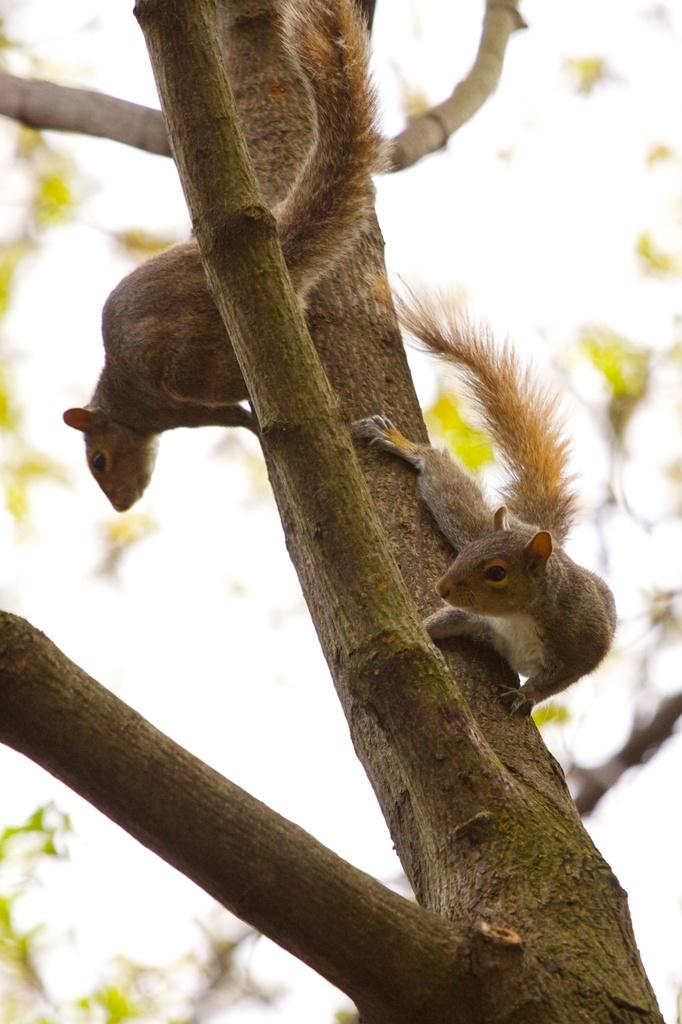What animals can be seen in the image? There are two squirrels in the image. Where are the squirrels located? The squirrels are on a tree trunk. Can you describe the background of the image? The background of the image is blurred. What type of brush is the ladybug using to paint the tree trunk in the image? There is no ladybug or brush present in the image; it features two squirrels on a tree trunk with a blurred background. 